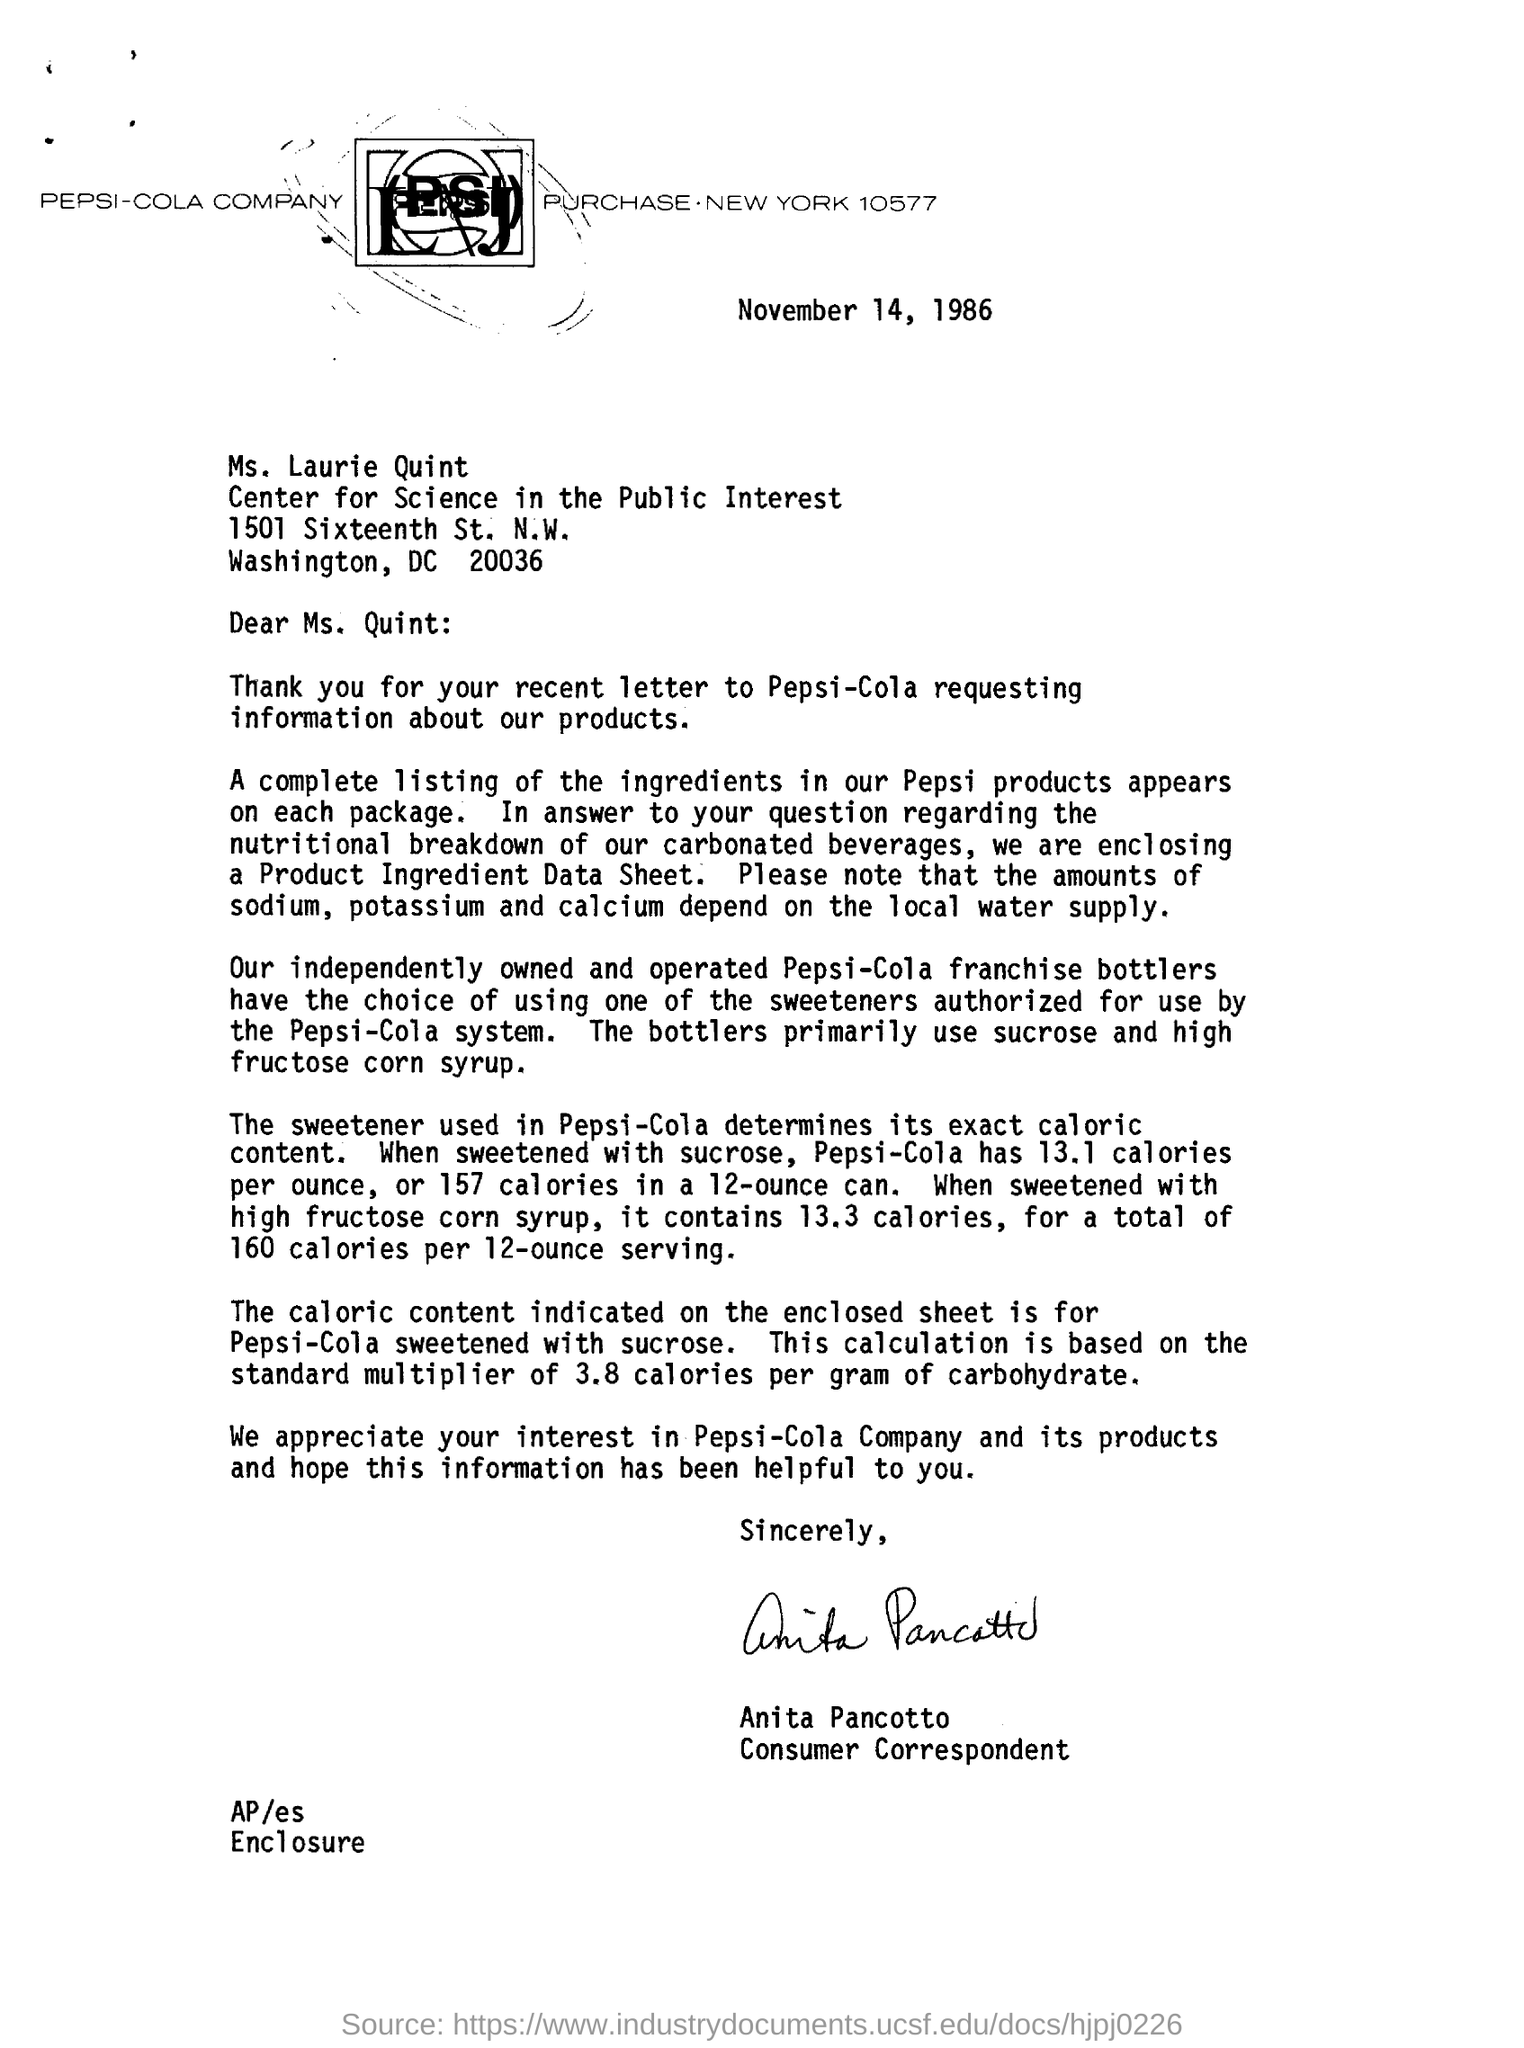List a handful of essential elements in this visual. Anita Pancotto is the consumer correspondent. The date mentioned at the top of the page is November 14, 1986. 